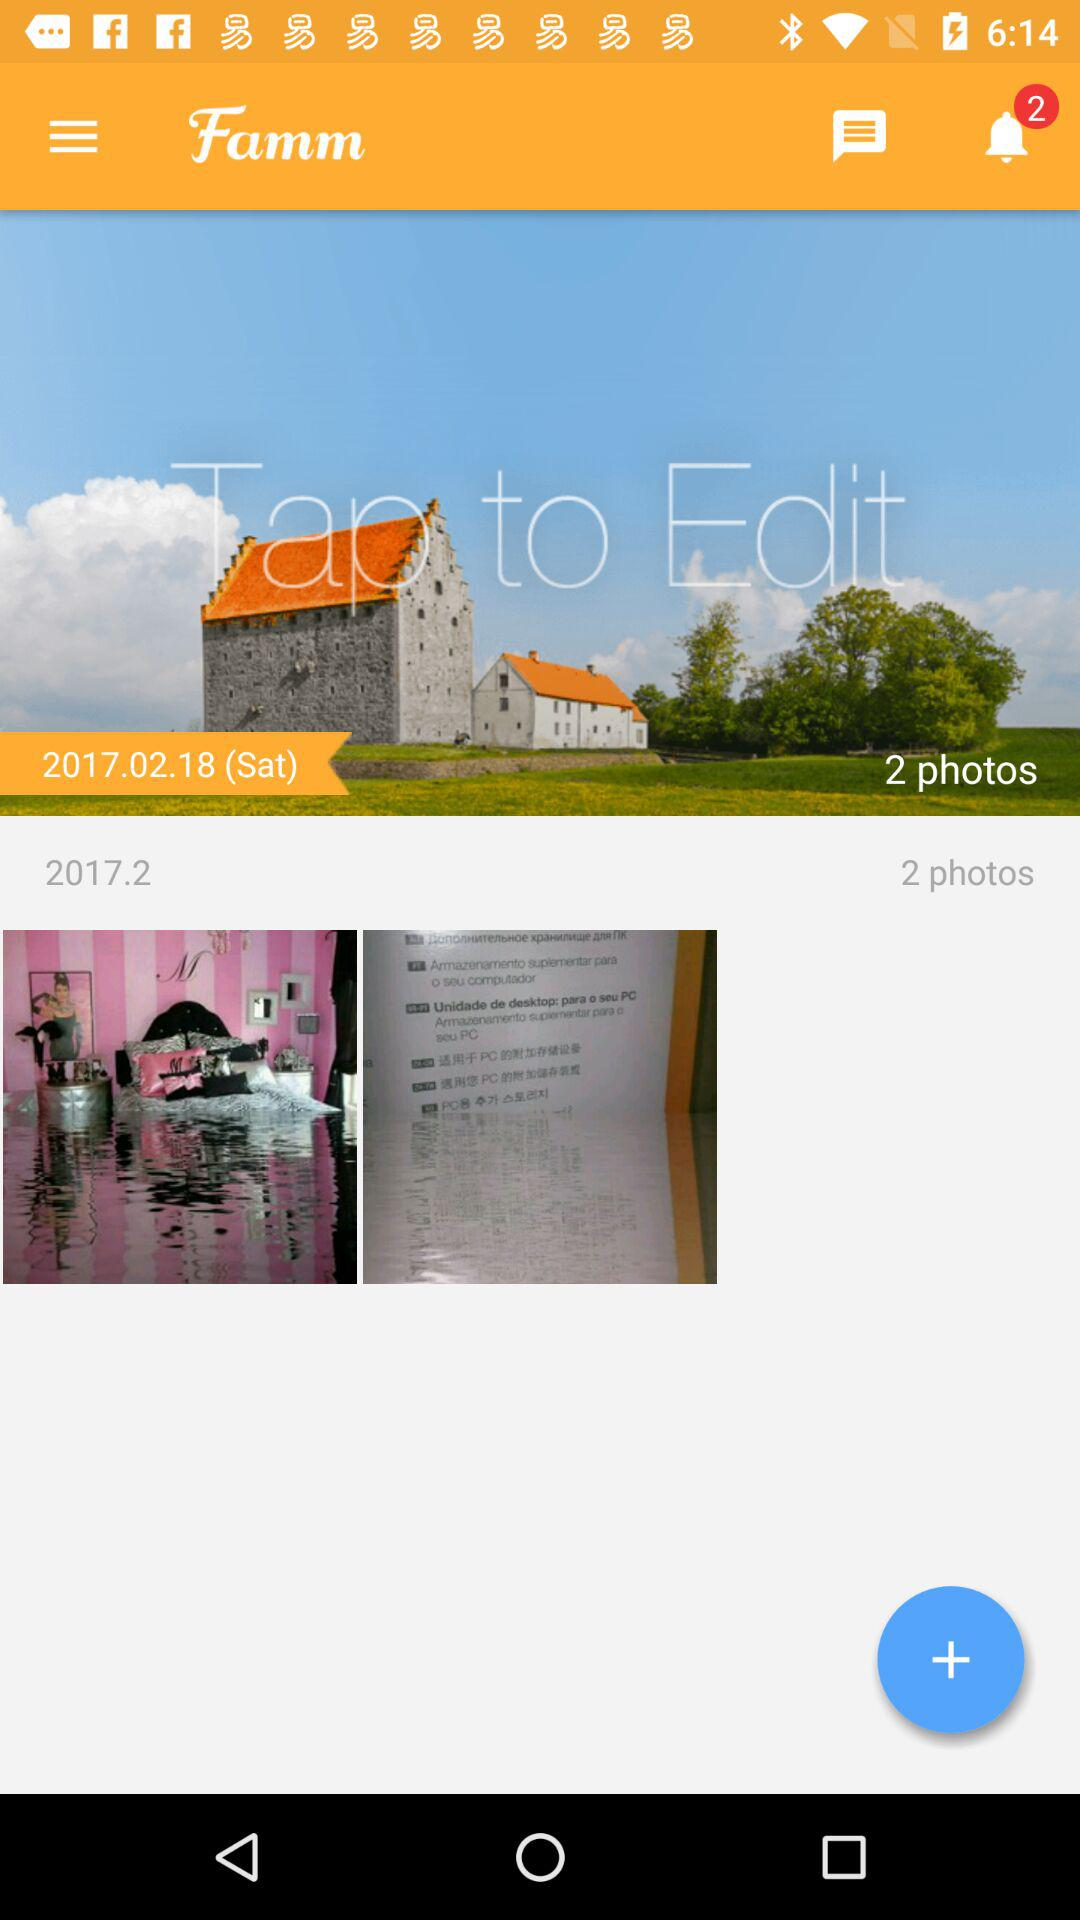How many total photos are there? There are 2 photos. 